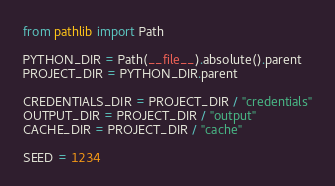<code> <loc_0><loc_0><loc_500><loc_500><_Python_>from pathlib import Path

PYTHON_DIR = Path(__file__).absolute().parent
PROJECT_DIR = PYTHON_DIR.parent

CREDENTIALS_DIR = PROJECT_DIR / "credentials"
OUTPUT_DIR = PROJECT_DIR / "output"
CACHE_DIR = PROJECT_DIR / "cache"

SEED = 1234
</code> 